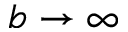Convert formula to latex. <formula><loc_0><loc_0><loc_500><loc_500>b \to \infty</formula> 